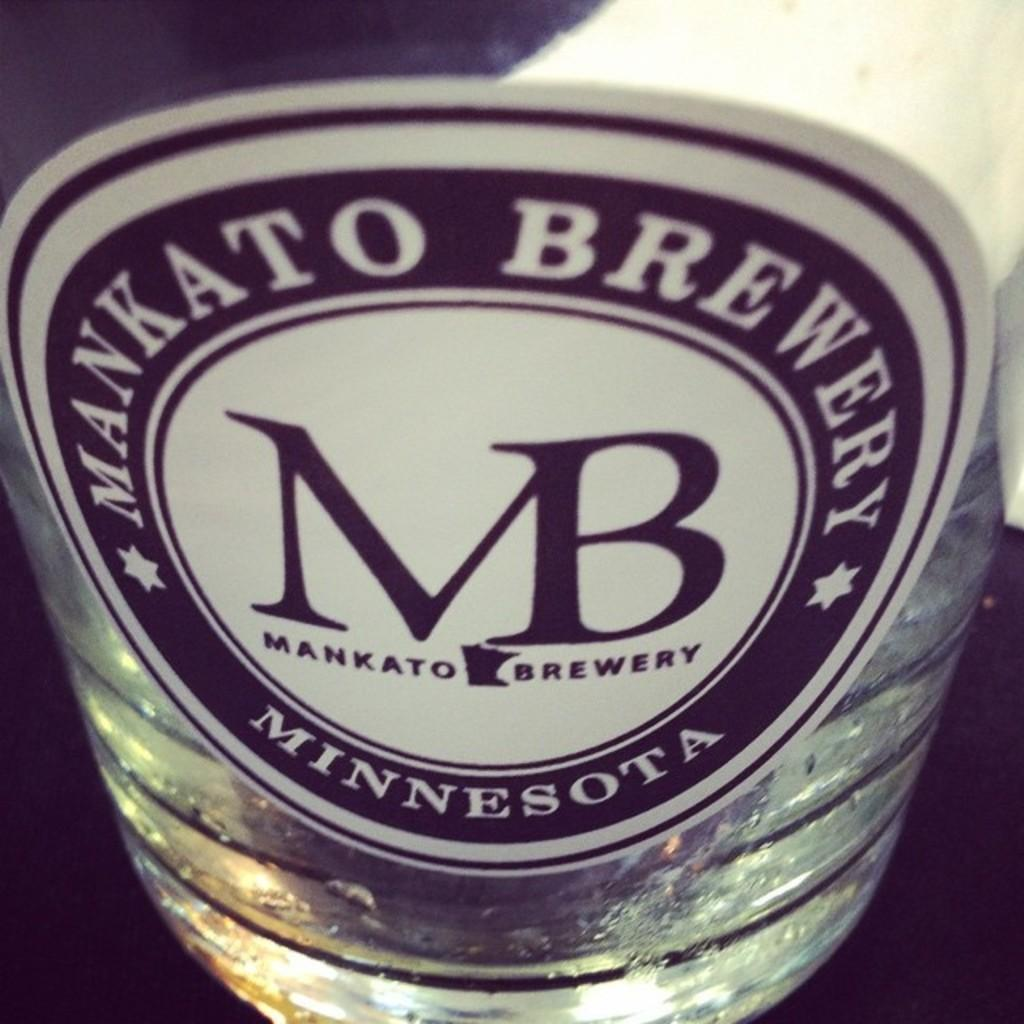<image>
Offer a succinct explanation of the picture presented. Front of mankato brewery beer or a keg 